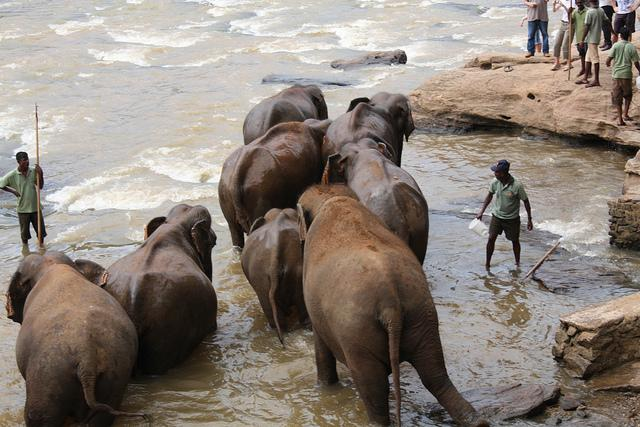Why is the person on the right of the elephants holding a bucket? washing 